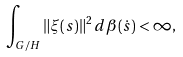<formula> <loc_0><loc_0><loc_500><loc_500>\int _ { G / H } \| \xi ( s ) \| ^ { 2 } \, d \beta ( \dot { s } ) < \infty ,</formula> 